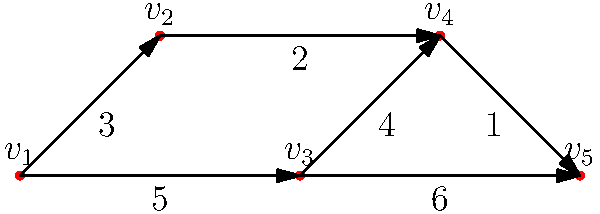In the textile manufacturing supply chain network of Ludhiana, each vertex represents a manufacturing unit or distribution center, and the edges represent transportation routes with their associated costs. Find the minimum cost path from vertex $v_1$ to vertex $v_5$ in the given graph. To find the minimum cost path from $v_1$ to $v_5$, we can use Dijkstra's algorithm:

1. Initialize:
   - Distance to $v_1$ = 0
   - Distance to all other vertices = $\infty$

2. Start from $v_1$:
   - Update neighbors: $v_2$ (3), $v_3$ (5)

3. Select vertex with minimum distance (v_2):
   - Update neighbors: $v_4$ (3 + 2 = 5)

4. Select vertex with minimum distance (v_3):
   - Update neighbors: $v_4$ (5 + 4 = 9), $v_5$ (5 + 6 = 11)

5. Select vertex with minimum distance (v_4):
   - Update neighbors: $v_5$ (5 + 1 = 6)

6. Select vertex with minimum distance (v_5):
   - All vertices visited

The minimum cost path is $v_1 \rightarrow v_2 \rightarrow v_4 \rightarrow v_5$ with a total cost of 6.
Answer: $v_1 \rightarrow v_2 \rightarrow v_4 \rightarrow v_5$, cost: 6 